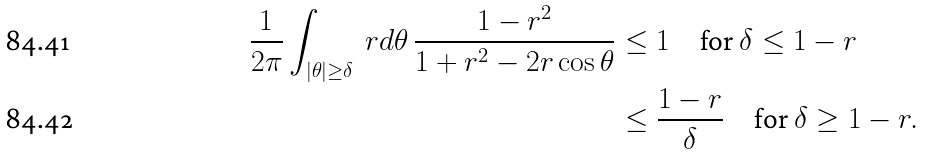<formula> <loc_0><loc_0><loc_500><loc_500>\frac { 1 } { 2 \pi } \int _ { | \theta | \geq \delta } \ r d \theta \, \frac { 1 - r ^ { 2 } } { 1 + r ^ { 2 } - 2 r \cos \theta } & \leq 1 \quad \text {for } \delta \leq 1 - r \\ & \leq \frac { 1 - r } { \delta } \quad \text {for } \delta \geq 1 - r .</formula> 